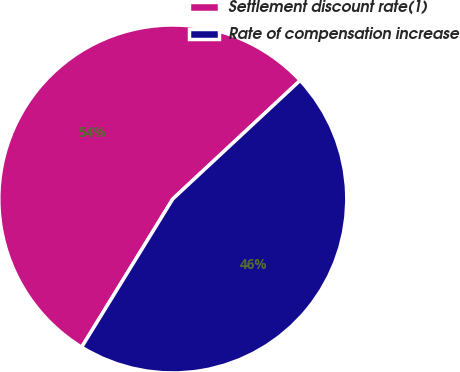Convert chart. <chart><loc_0><loc_0><loc_500><loc_500><pie_chart><fcel>Settlement discount rate(1)<fcel>Rate of compensation increase<nl><fcel>54.29%<fcel>45.71%<nl></chart> 